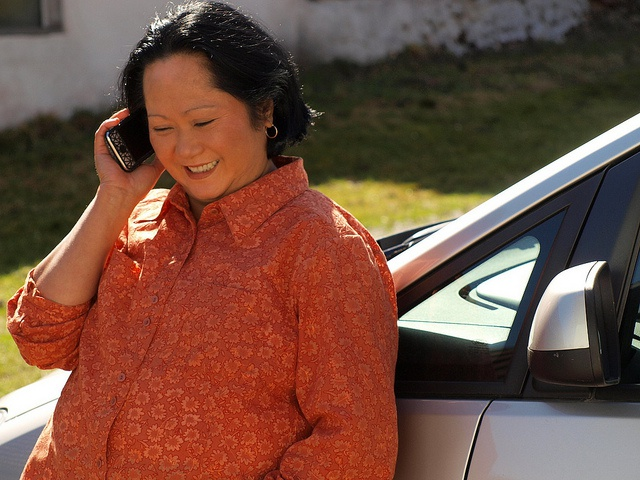Describe the objects in this image and their specific colors. I can see people in black, brown, and maroon tones, car in black, ivory, darkgray, and gray tones, and cell phone in black, maroon, gray, and brown tones in this image. 